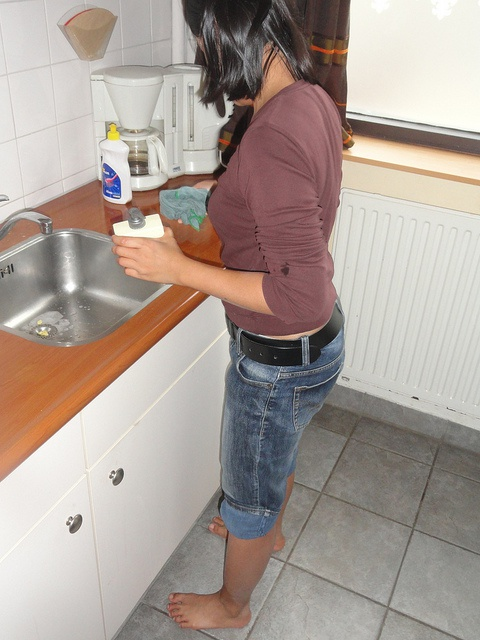Describe the objects in this image and their specific colors. I can see people in lightgray, gray, brown, black, and darkgray tones, sink in lightgray, darkgray, and gray tones, and bottle in lightgray, blue, and darkgray tones in this image. 